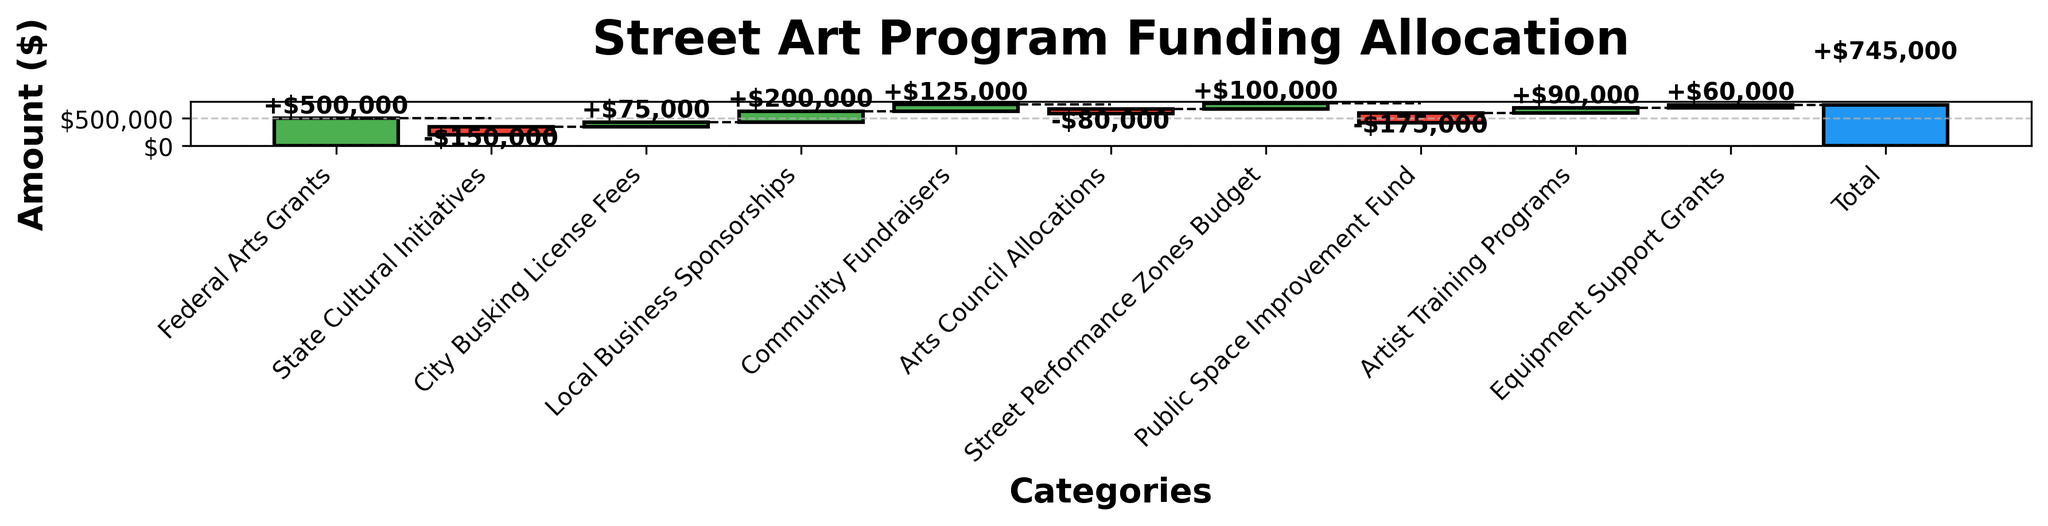How much funding did the Street Performance Zones Budget receive? Identify the "Street Performance Zones Budget" category in the chart and check the height of the bar corresponding to that category.
Answer: $100,000 Which category contributed the largest positive amount? Compare the heights of all the bars with positive values and identify the highest one. The "Federal Arts Grants" bar is the tallest among positive values.
Answer: Federal Arts Grants What is the total funding allocation for street art programs? Identify the "Total" category in the chart to find the total funding allocation. The figure shows this value at the end of the cumulative bars.
Answer: $745,000 How did the State Cultural Initiatives impact the total funding? Locate the "State Cultural Initiatives" bar, which is negative, and check its value. Subtract the value from the previous cumulative sum to see its impact.
Answer: Decreased by $150,000 What is the net effect of the City Busking License Fees and Local Business Sponsorships combined? Add the values of the "City Busking License Fees" and "Local Business Sponsorships" categories: $75,000 + $200,000.
Answer: $275,000 Which category has the highest negative impact on funding? Compare the heights of all the negative bars and identify the lowest one. The "Public Space Improvement Fund" bar is the lowest among negative values.
Answer: Public Space Improvement Fund What is the cumulative funding amount right after the Arts Council Allocations? Observe the point just after the "Arts Council Allocations" bar and find the cumulative total at that step. Cumulative at that point is calculated up to that bar only.
Answer: $345,000 From the positive categories, which one has the smallest contribution? Compare the heights of all the positive bars and identify the shortest one. The "Equipment Support Grants" bar is the shortest among positive values.
Answer: Equipment Support Grants How does the funding from Community Fundraisers compare to the Equipment Support Grants? Locate the bars for "Community Fundraisers" and "Equipment Support Grants", then compare their heights. "Community Fundraisers" is taller.
Answer: Greater What's the total contribution of all negative categories combined? Add up the values of all negative categories: -$150,000 (State Cultural Initiatives) + -$80,000 (Arts Council Allocations) + -$175,000 (Public Space Improvement Fund).
Answer: -$405,000 